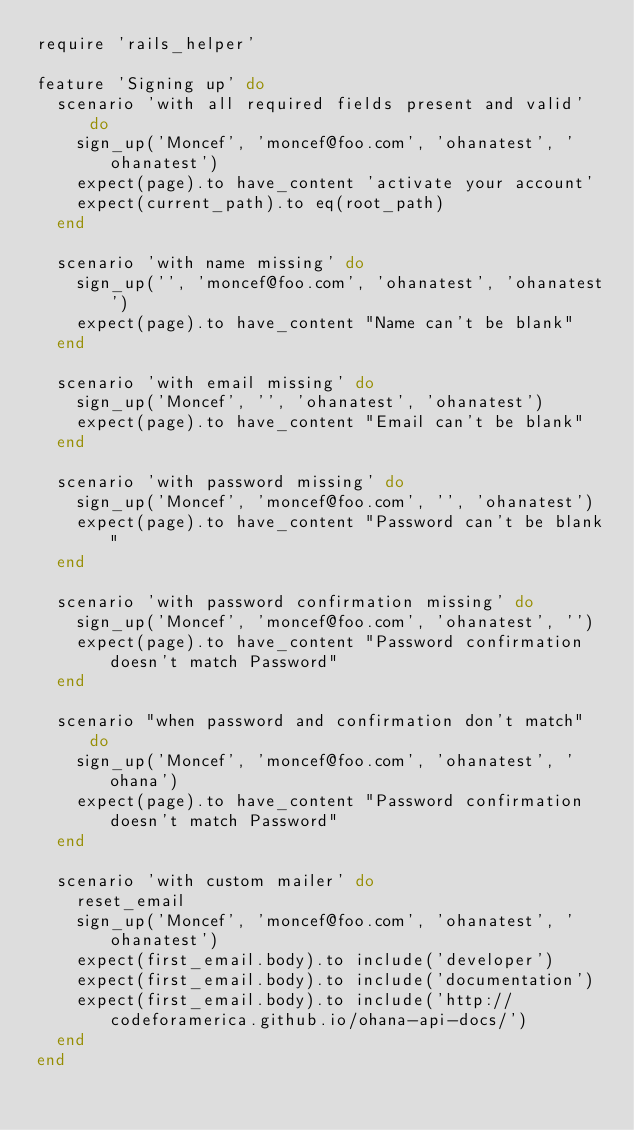Convert code to text. <code><loc_0><loc_0><loc_500><loc_500><_Ruby_>require 'rails_helper'

feature 'Signing up' do
  scenario 'with all required fields present and valid' do
    sign_up('Moncef', 'moncef@foo.com', 'ohanatest', 'ohanatest')
    expect(page).to have_content 'activate your account'
    expect(current_path).to eq(root_path)
  end

  scenario 'with name missing' do
    sign_up('', 'moncef@foo.com', 'ohanatest', 'ohanatest')
    expect(page).to have_content "Name can't be blank"
  end

  scenario 'with email missing' do
    sign_up('Moncef', '', 'ohanatest', 'ohanatest')
    expect(page).to have_content "Email can't be blank"
  end

  scenario 'with password missing' do
    sign_up('Moncef', 'moncef@foo.com', '', 'ohanatest')
    expect(page).to have_content "Password can't be blank"
  end

  scenario 'with password confirmation missing' do
    sign_up('Moncef', 'moncef@foo.com', 'ohanatest', '')
    expect(page).to have_content "Password confirmation doesn't match Password"
  end

  scenario "when password and confirmation don't match" do
    sign_up('Moncef', 'moncef@foo.com', 'ohanatest', 'ohana')
    expect(page).to have_content "Password confirmation doesn't match Password"
  end

  scenario 'with custom mailer' do
    reset_email
    sign_up('Moncef', 'moncef@foo.com', 'ohanatest', 'ohanatest')
    expect(first_email.body).to include('developer')
    expect(first_email.body).to include('documentation')
    expect(first_email.body).to include('http://codeforamerica.github.io/ohana-api-docs/')
  end
end
</code> 